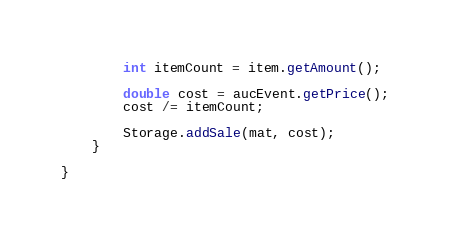<code> <loc_0><loc_0><loc_500><loc_500><_Java_>
        int itemCount = item.getAmount();

        double cost = aucEvent.getPrice();
        cost /= itemCount;

        Storage.addSale(mat, cost);
    }

}
</code> 